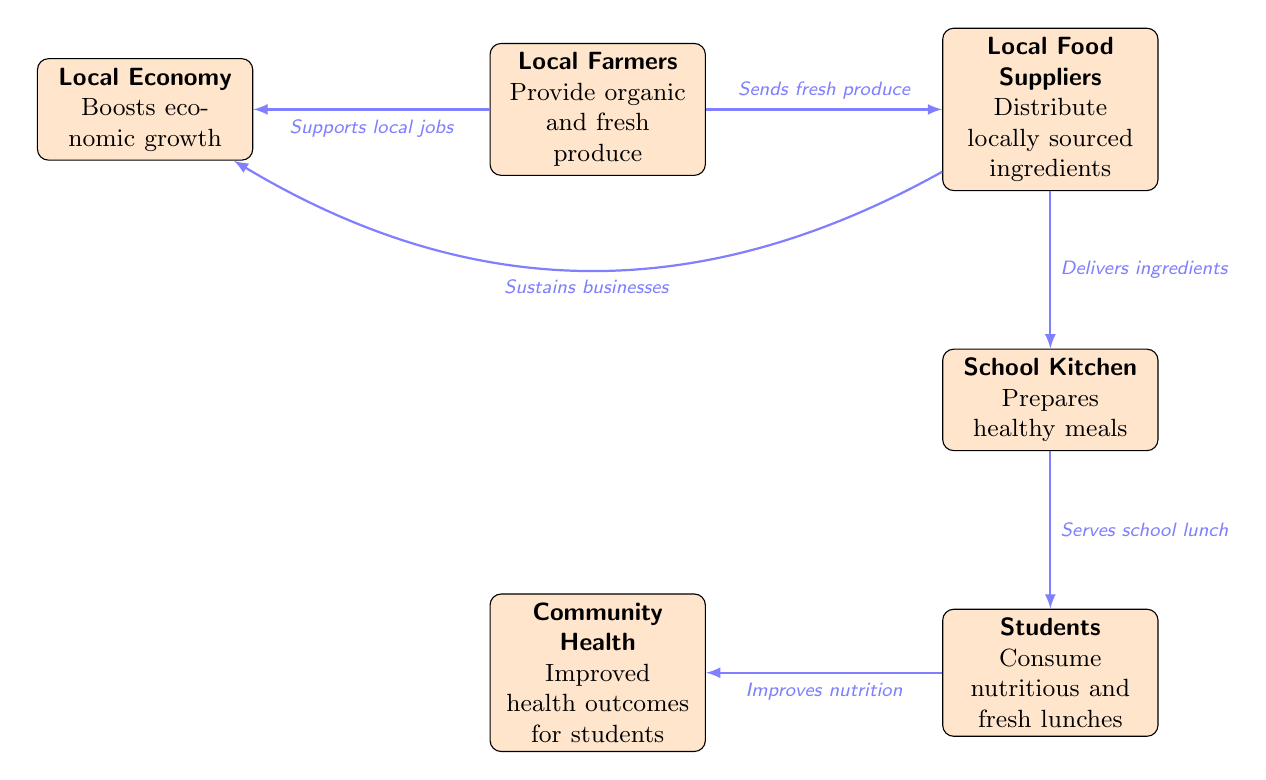What do local farmers provide for the food suppliers? According to the diagram, local farmers provide "organic and fresh produce" to the food suppliers. This is clearly stated in the node representing the local farmers.
Answer: organic and fresh produce What is the role of the school kitchen? The diagram specifies that the school kitchen "prepares healthy meals." This is directly indicated in the corresponding node for the school kitchen.
Answer: prepares healthy meals How many nodes are there in the diagram? By counting all unique entities represented in the diagram, including local farmers, food suppliers, school kitchen, students, community health, and local economy, we find there are 6 nodes in total.
Answer: 6 What is the relationship between students and community health? The diagram establishes that students improve community health by consuming nutritious and fresh lunches. This is illustrated by the arrow connecting the students' node to the community health node with the text "Improves nutrition."
Answer: Improves nutrition Which node indicates the impact on the local economy? The diagram shows that both local farmers and local food suppliers positively impact the local economy. This information is presented in their respective nodes linked with the phrases "Supports local jobs" and "Sustains businesses."
Answer: local economy What do local food suppliers distribute? The diagram clearly states that local food suppliers "distribute locally sourced ingredients." This statement is directly available in the node regarding local food suppliers.
Answer: locally sourced ingredients What impact do local farmers have on the local economy? The diagram shows that local farmers support the local economy by "boosting economic growth." This is specifically noted in the local economy node connected to local farmers.
Answer: Boosts economic growth Which entity serves the school lunch? The school kitchen is responsible for serving the school lunch according to the diagram, as indicated by the connection from the school kitchen to the students with the label "Serves school lunch."
Answer: School Kitchen 